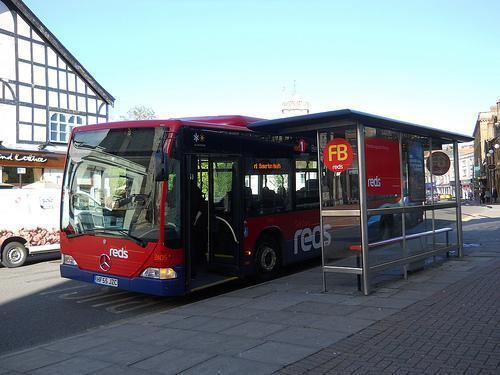How many wheels can be seen?
Give a very brief answer. 3. 